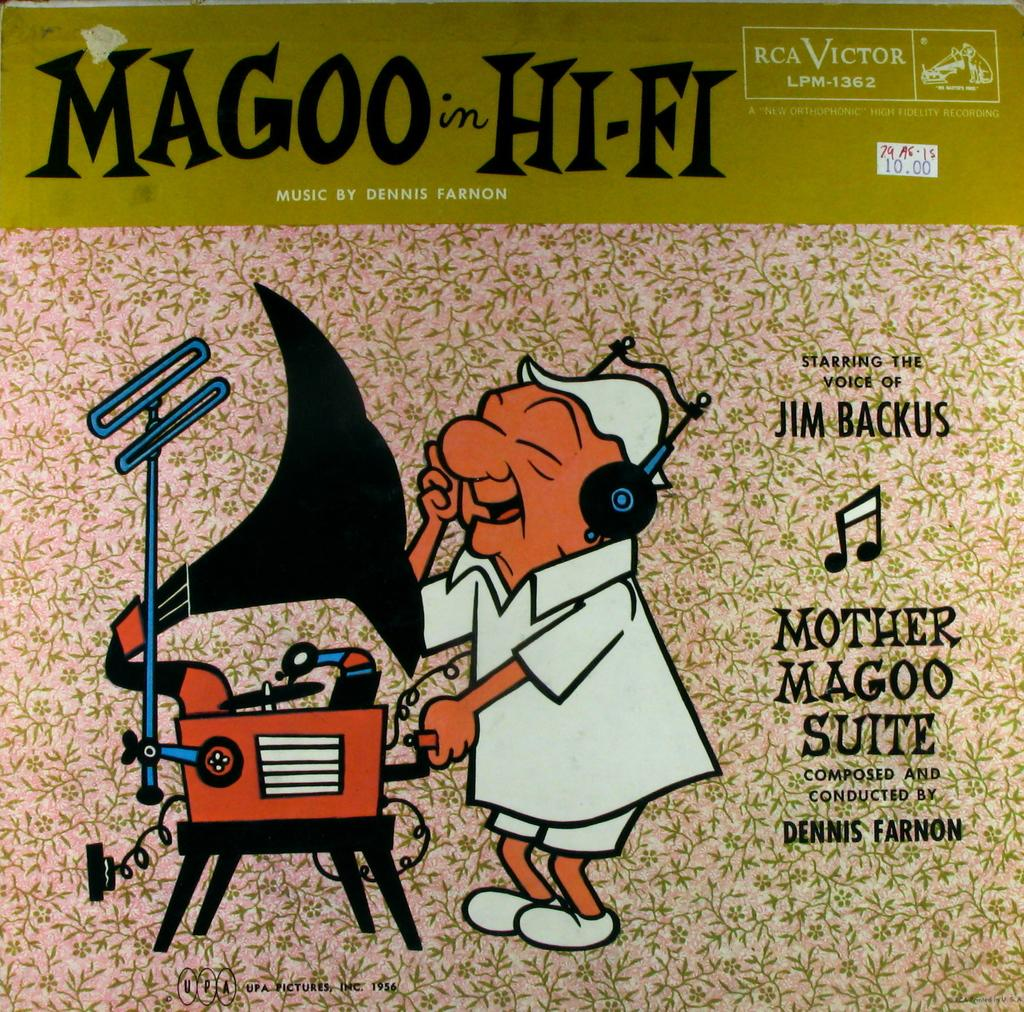What type of visual is the image? The image is a poster. Who or what is depicted in the poster? There is a person in the poster. What is the person wearing on their head? The person is wearing a cap. What is in front of the person in the poster? There is a stand and a device in front of the person. How many lizards can be seen crawling on the device in the poster? There are no lizards present in the image, so it is not possible to determine how many might be crawling on the device. 